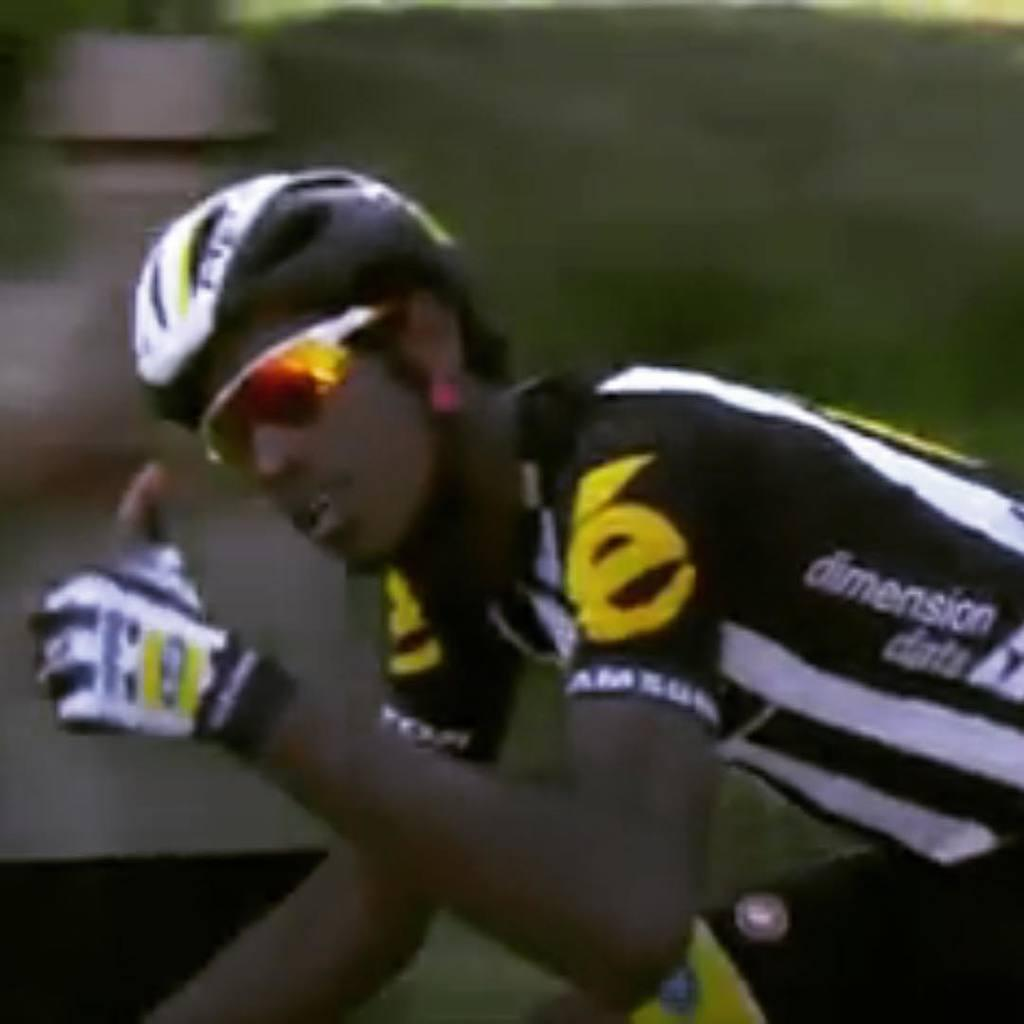Who or what is present in the image? There is a person in the image. What protective gear is the person wearing? The person is wearing a helmet. What type of eyewear is the person wearing? The person is wearing glasses. Can you describe the background of the image? The background of the image is blurred and green. What type of bread can be seen in the person's hand in the image? There is no bread present in the image; the person is wearing a helmet and glasses, and the background is blurred and green. 